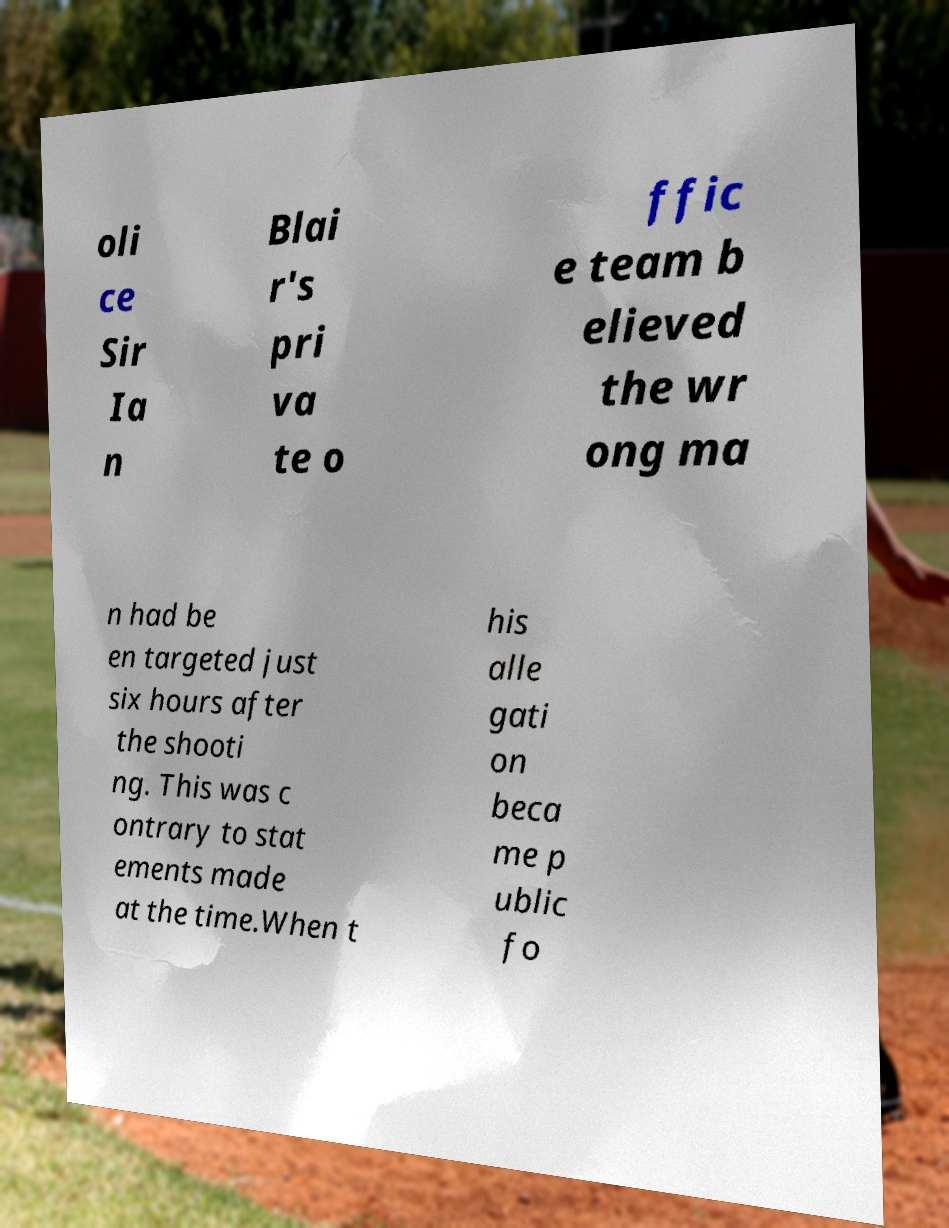What messages or text are displayed in this image? I need them in a readable, typed format. oli ce Sir Ia n Blai r's pri va te o ffic e team b elieved the wr ong ma n had be en targeted just six hours after the shooti ng. This was c ontrary to stat ements made at the time.When t his alle gati on beca me p ublic fo 